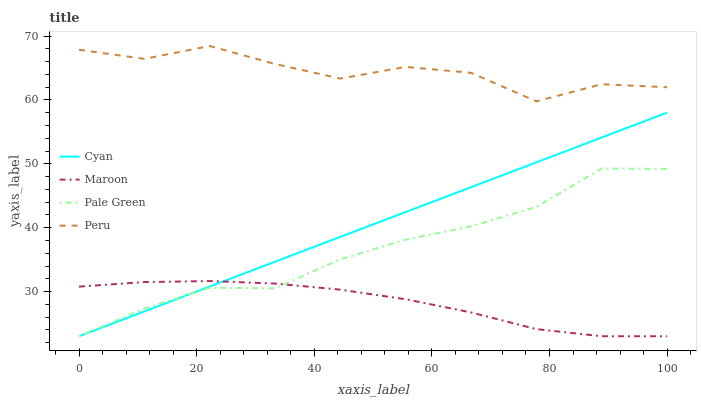Does Maroon have the minimum area under the curve?
Answer yes or no. Yes. Does Peru have the maximum area under the curve?
Answer yes or no. Yes. Does Pale Green have the minimum area under the curve?
Answer yes or no. No. Does Pale Green have the maximum area under the curve?
Answer yes or no. No. Is Cyan the smoothest?
Answer yes or no. Yes. Is Peru the roughest?
Answer yes or no. Yes. Is Pale Green the smoothest?
Answer yes or no. No. Is Pale Green the roughest?
Answer yes or no. No. Does Cyan have the lowest value?
Answer yes or no. Yes. Does Peru have the lowest value?
Answer yes or no. No. Does Peru have the highest value?
Answer yes or no. Yes. Does Pale Green have the highest value?
Answer yes or no. No. Is Cyan less than Peru?
Answer yes or no. Yes. Is Peru greater than Cyan?
Answer yes or no. Yes. Does Cyan intersect Maroon?
Answer yes or no. Yes. Is Cyan less than Maroon?
Answer yes or no. No. Is Cyan greater than Maroon?
Answer yes or no. No. Does Cyan intersect Peru?
Answer yes or no. No. 